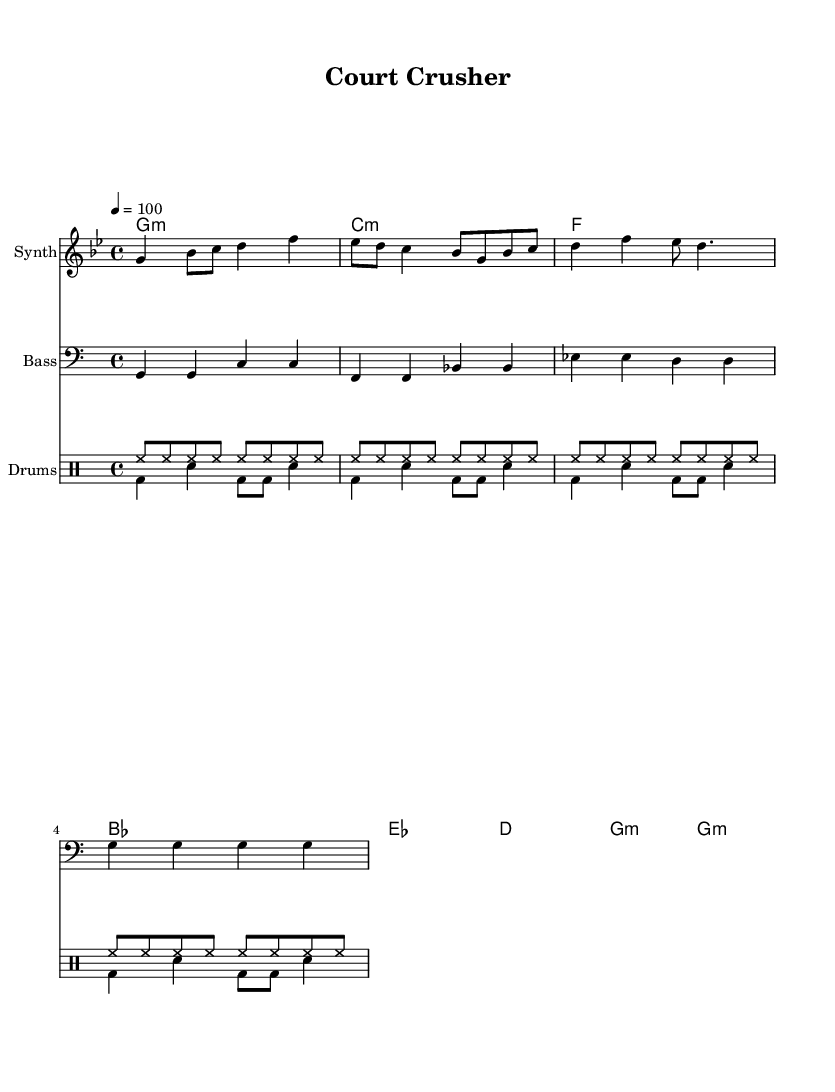What is the key signature of this music? The key signature is G minor, which has two flats (B♭ and E♭).
Answer: G minor What is the time signature of this music? The time signature is 4/4, indicating four beats per measure.
Answer: 4/4 What is the tempo marking for this piece? The tempo marking is indicated as quarter note equals 100 beats per minute.
Answer: 100 How many distinct voices are present in the drum section? There are two distinct drum voices: one playing the hi-hat and the other the bass drum and snare drum.
Answer: Two Which chord is played in the first measure? The first measure features a G minor chord.
Answer: G minor What type of mood does the combination of instruments convey? The combination of synthesizer, bass, and energetic drums creates an upbeat and motivational mood, typical for pump-up hip-hop tracks.
Answer: Upbeat How many measures are there in the melody? The melody consists of four measures.
Answer: Four 